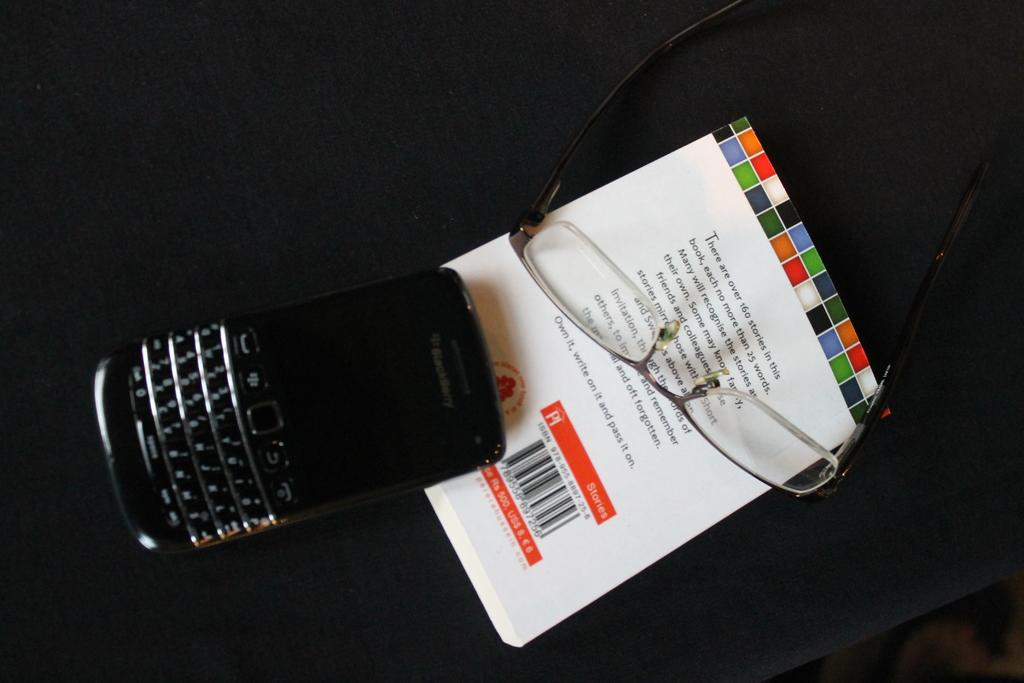<image>
Describe the image concisely. A BlackBerry mobile phone and a pair of glasses rest upon a book of short stories. 